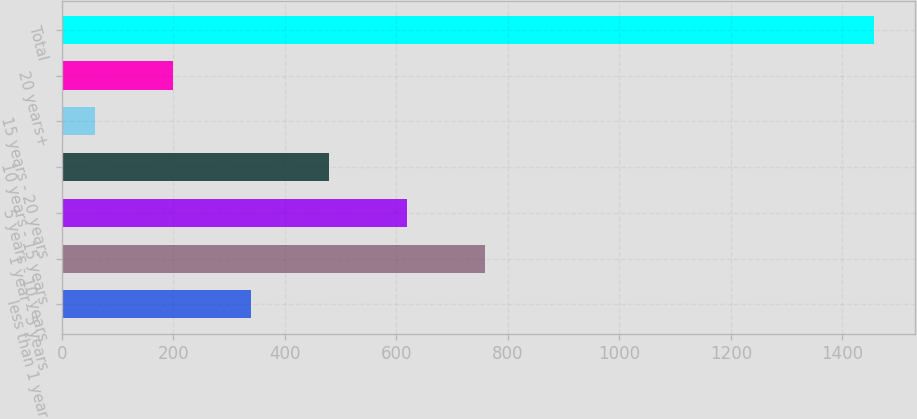Convert chart. <chart><loc_0><loc_0><loc_500><loc_500><bar_chart><fcel>less than 1 year<fcel>1 year - 5 years<fcel>5 years - 10 years<fcel>10 years - 15 years<fcel>15 years - 20 years<fcel>20 years+<fcel>Total<nl><fcel>339.4<fcel>758.5<fcel>618.8<fcel>479.1<fcel>60<fcel>199.7<fcel>1457<nl></chart> 